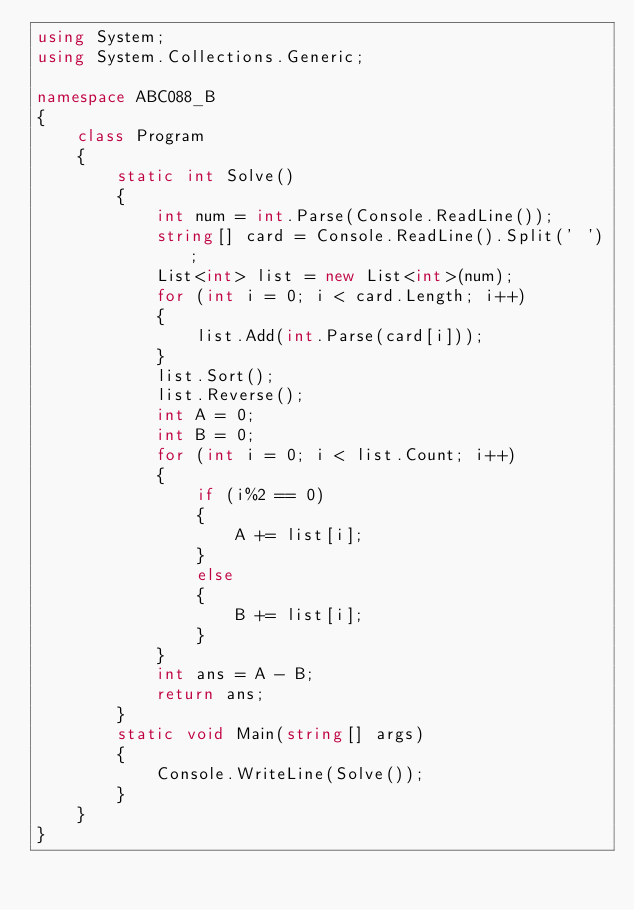<code> <loc_0><loc_0><loc_500><loc_500><_C#_>using System;
using System.Collections.Generic;

namespace ABC088_B
{
    class Program
    {
        static int Solve()
        {
            int num = int.Parse(Console.ReadLine());
            string[] card = Console.ReadLine().Split(' ');
            List<int> list = new List<int>(num);
            for (int i = 0; i < card.Length; i++)
            {
                list.Add(int.Parse(card[i]));
            }
            list.Sort();
            list.Reverse();
            int A = 0;
            int B = 0;
            for (int i = 0; i < list.Count; i++)
            {
                if (i%2 == 0)
                {
                    A += list[i];
                }
                else
                {
                    B += list[i];
                }
            }
            int ans = A - B;
            return ans;
        }
        static void Main(string[] args)
        {
            Console.WriteLine(Solve());
        }
    }
}
</code> 